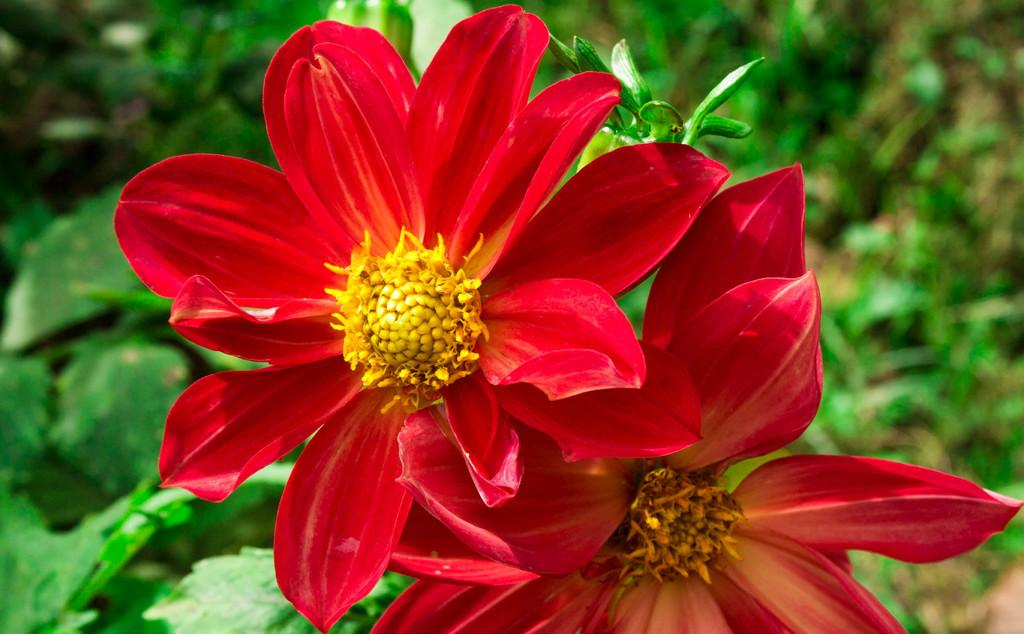What type of flowers can be seen in the image? There are red colored flowers in the image. Can you describe the background of the image? The background of the image is blurred. What type of music is being played in the background of the image? There is no music present in the image; it only features red colored flowers and a blurred background. 